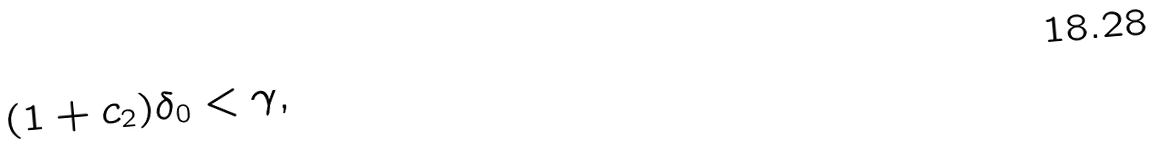<formula> <loc_0><loc_0><loc_500><loc_500>( 1 + c _ { 2 } ) \delta _ { 0 } < \gamma ,</formula> 